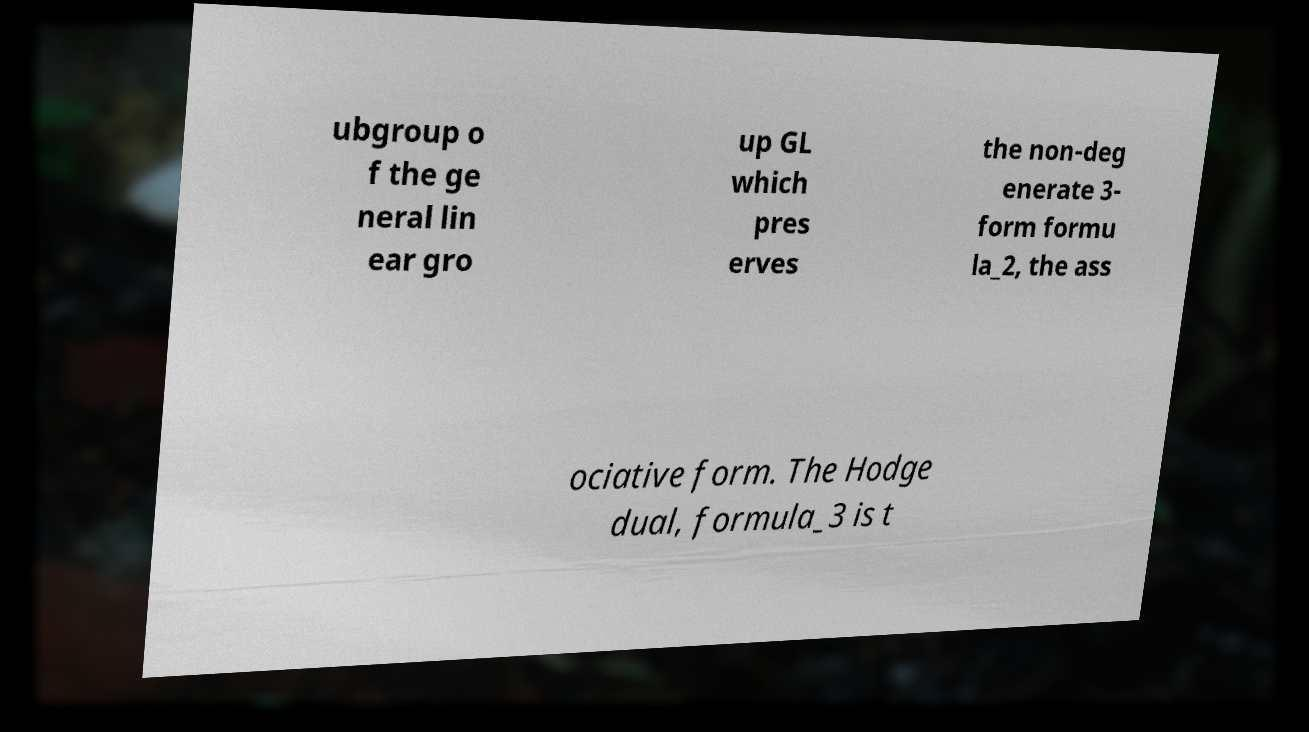Can you read and provide the text displayed in the image?This photo seems to have some interesting text. Can you extract and type it out for me? ubgroup o f the ge neral lin ear gro up GL which pres erves the non-deg enerate 3- form formu la_2, the ass ociative form. The Hodge dual, formula_3 is t 